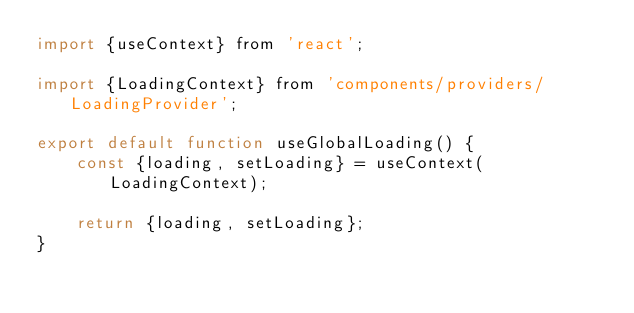<code> <loc_0><loc_0><loc_500><loc_500><_JavaScript_>import {useContext} from 'react';

import {LoadingContext} from 'components/providers/LoadingProvider';

export default function useGlobalLoading() {
    const {loading, setLoading} = useContext(LoadingContext);

    return {loading, setLoading};
}
</code> 